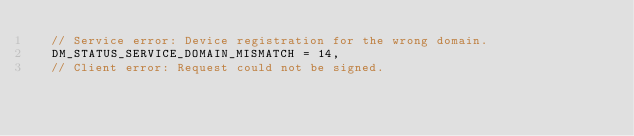<code> <loc_0><loc_0><loc_500><loc_500><_C_>  // Service error: Device registration for the wrong domain.
  DM_STATUS_SERVICE_DOMAIN_MISMATCH = 14,
  // Client error: Request could not be signed.</code> 